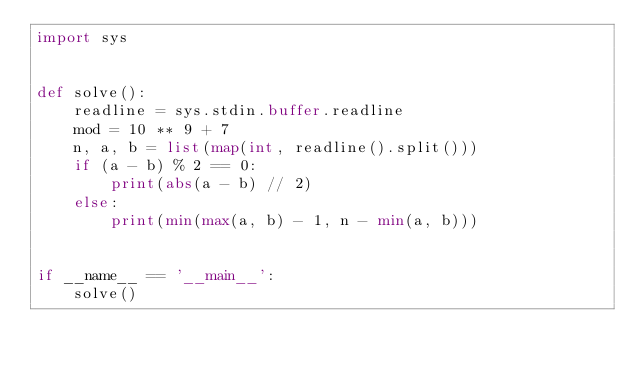Convert code to text. <code><loc_0><loc_0><loc_500><loc_500><_Python_>import sys


def solve():
    readline = sys.stdin.buffer.readline
    mod = 10 ** 9 + 7
    n, a, b = list(map(int, readline().split()))
    if (a - b) % 2 == 0:
        print(abs(a - b) // 2)
    else:
        print(min(max(a, b) - 1, n - min(a, b)))


if __name__ == '__main__':
    solve()
</code> 